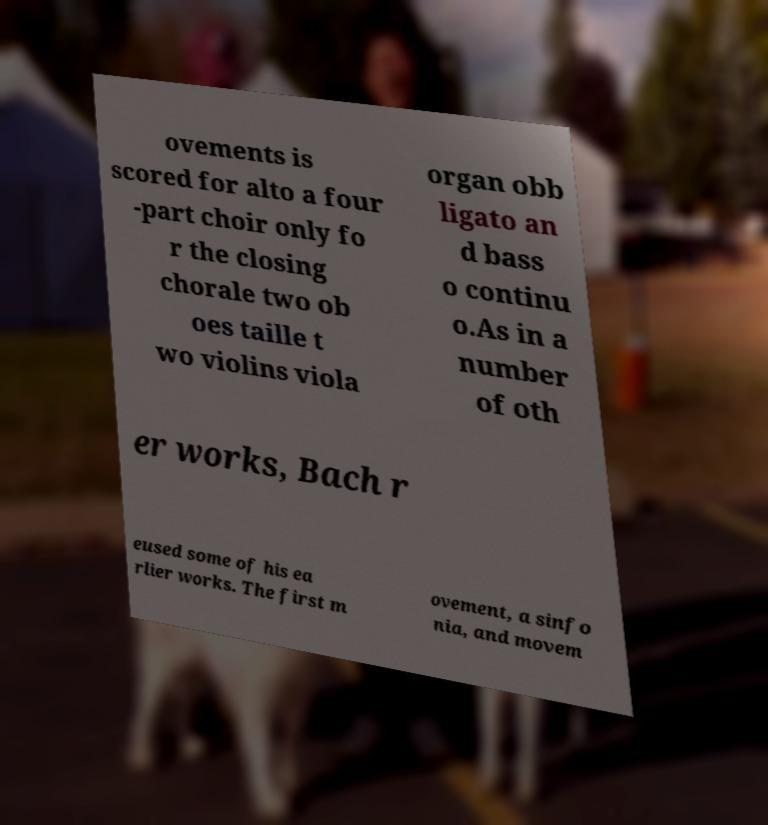Could you assist in decoding the text presented in this image and type it out clearly? ovements is scored for alto a four -part choir only fo r the closing chorale two ob oes taille t wo violins viola organ obb ligato an d bass o continu o.As in a number of oth er works, Bach r eused some of his ea rlier works. The first m ovement, a sinfo nia, and movem 